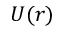<formula> <loc_0><loc_0><loc_500><loc_500>U ( r )</formula> 